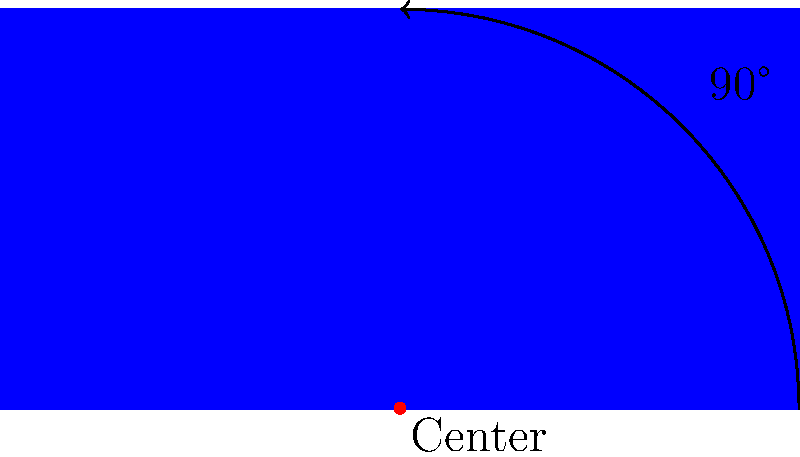Imagine you're designing a new social media app icon for America's Got Talent. If you rotate the square app icon by 90 degrees clockwise around its center, which of the following transformations would correctly describe this rotation?

A) $(x, y) \rightarrow (-y, x)$
B) $(x, y) \rightarrow (y, -x)$
C) $(x, y) \rightarrow (-x, -y)$
D) $(x, y) \rightarrow (y, x)$ Let's approach this step-by-step:

1) In transformational geometry, a 90-degree clockwise rotation around the origin is represented by the transformation $(x, y) \rightarrow (y, -x)$.

2) This is because:
   - The x-coordinate of the rotated point becomes the original y-coordinate.
   - The y-coordinate of the rotated point becomes the negative of the original x-coordinate.

3) We can verify this by considering a point $(a, b)$ on the original icon:
   - After a 90-degree clockwise rotation, this point would move to $(b, -a)$.

4) This transformation preserves the shape and size of the icon, which is crucial for maintaining the design integrity of your AGT social media app icon.

5) Looking at the options:
   A) $(x, y) \rightarrow (-y, x)$ represents a 90-degree counterclockwise rotation.
   B) $(x, y) \rightarrow (y, -x)$ represents a 90-degree clockwise rotation.
   C) $(x, y) \rightarrow (-x, -y)$ represents a 180-degree rotation.
   D) $(x, y) \rightarrow (y, x)$ is not a valid rotation transformation.

Therefore, the correct transformation for a 90-degree clockwise rotation of your AGT app icon is option B: $(x, y) \rightarrow (y, -x)$.
Answer: $(x, y) \rightarrow (y, -x)$ 